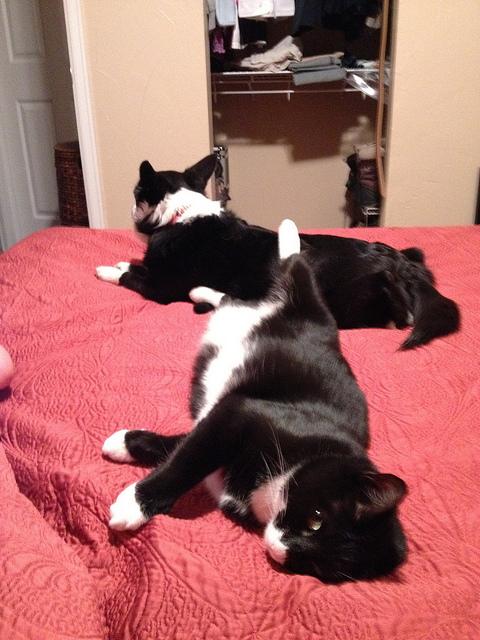Are the cat and dog enemies?
Quick response, please. No. Where are the animals laying?
Keep it brief. Bed. Are the cat and the dog attached to each other?
Quick response, please. No. 